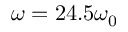Convert formula to latex. <formula><loc_0><loc_0><loc_500><loc_500>\omega = 2 4 . 5 \omega _ { 0 }</formula> 